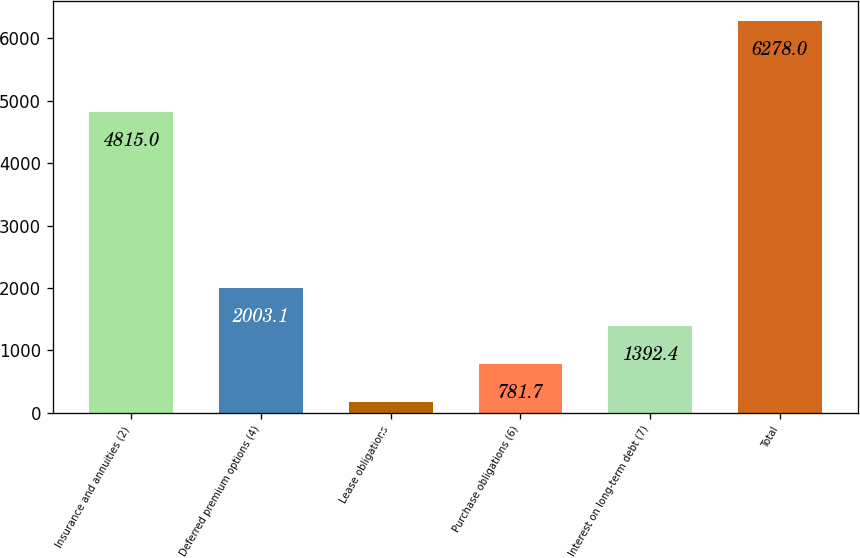<chart> <loc_0><loc_0><loc_500><loc_500><bar_chart><fcel>Insurance and annuities (2)<fcel>Deferred premium options (4)<fcel>Lease obligations<fcel>Purchase obligations (6)<fcel>Interest on long-term debt (7)<fcel>Total<nl><fcel>4815<fcel>2003.1<fcel>171<fcel>781.7<fcel>1392.4<fcel>6278<nl></chart> 